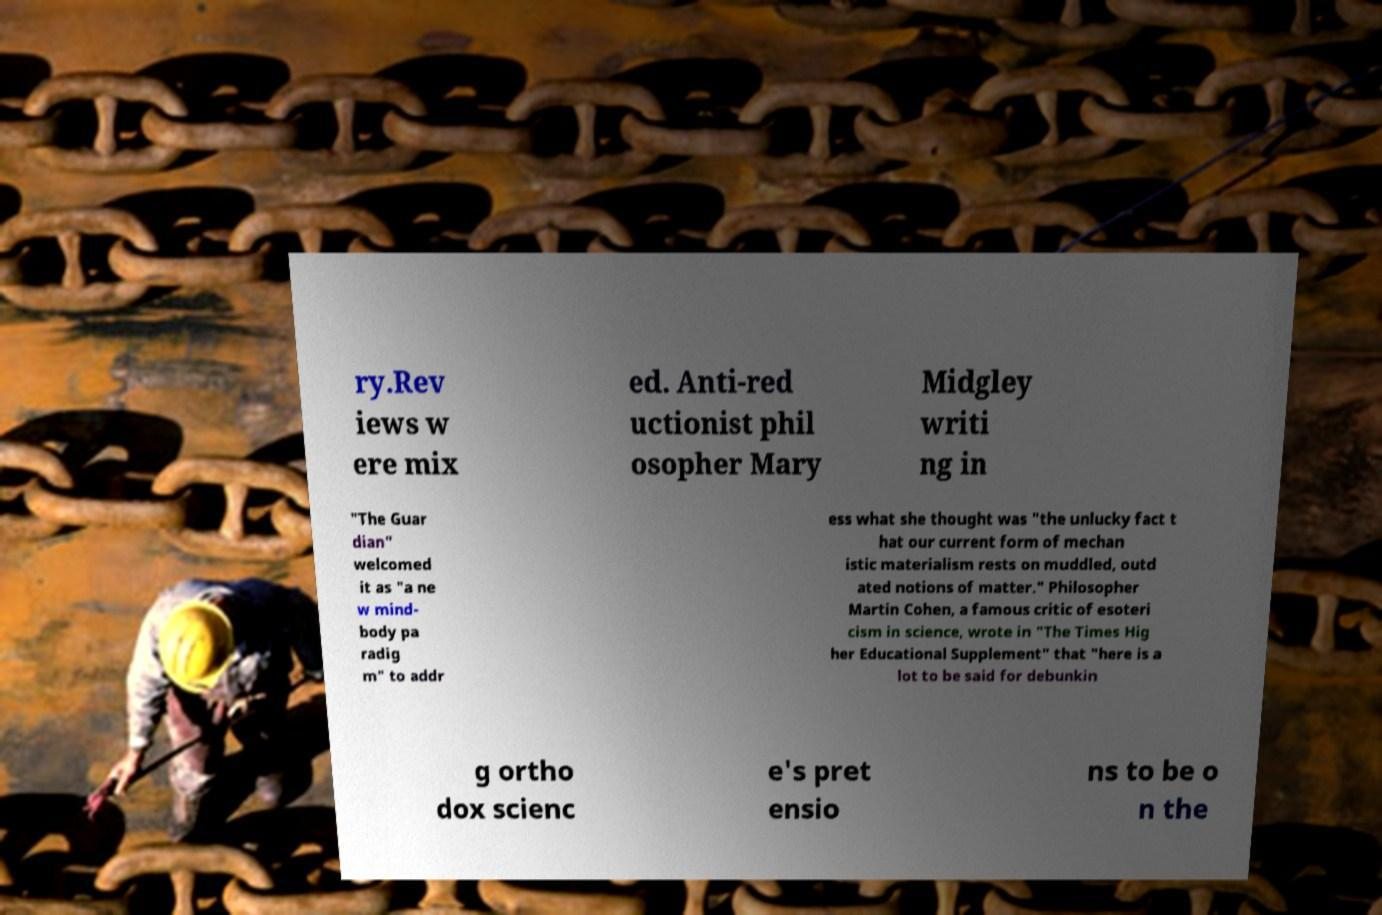I need the written content from this picture converted into text. Can you do that? ry.Rev iews w ere mix ed. Anti-red uctionist phil osopher Mary Midgley writi ng in "The Guar dian" welcomed it as "a ne w mind- body pa radig m" to addr ess what she thought was "the unlucky fact t hat our current form of mechan istic materialism rests on muddled, outd ated notions of matter." Philosopher Martin Cohen, a famous critic of esoteri cism in science, wrote in "The Times Hig her Educational Supplement" that "here is a lot to be said for debunkin g ortho dox scienc e's pret ensio ns to be o n the 